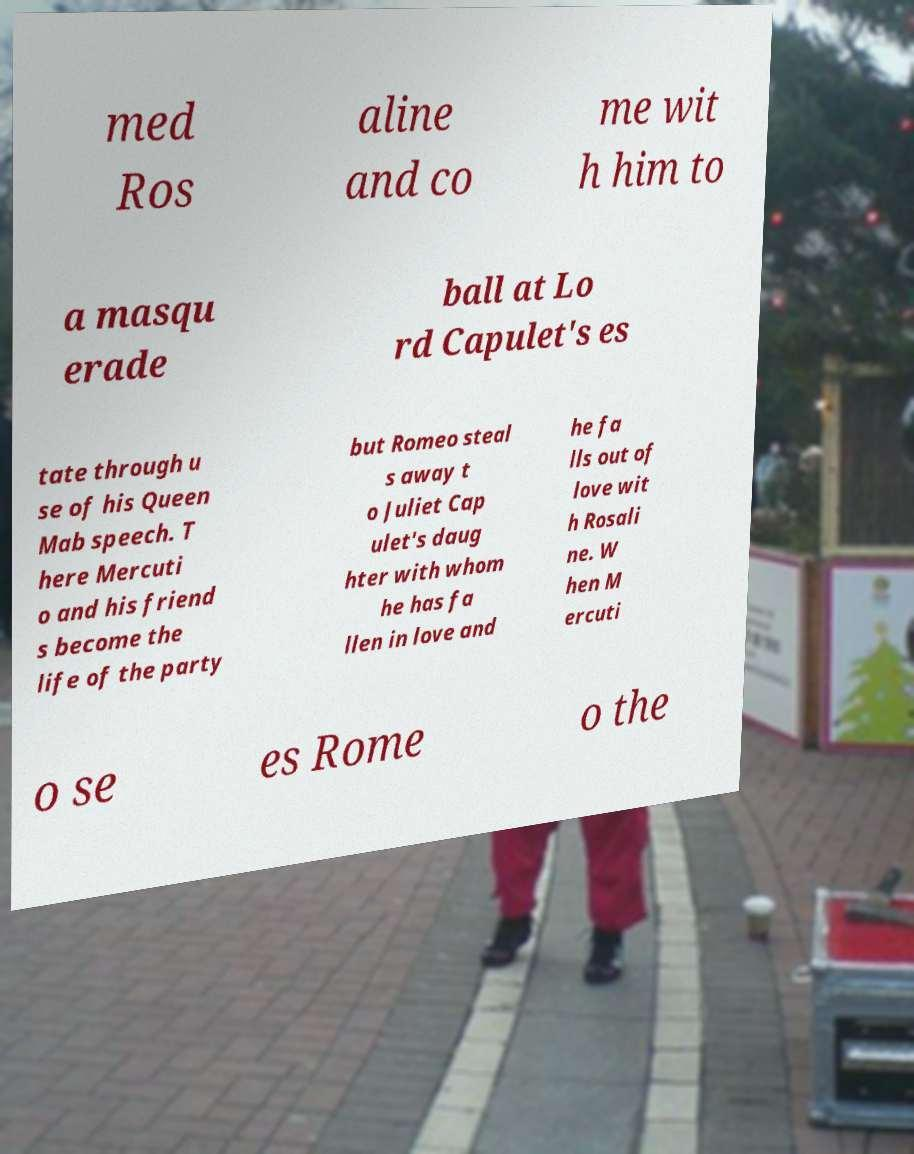Could you extract and type out the text from this image? med Ros aline and co me wit h him to a masqu erade ball at Lo rd Capulet's es tate through u se of his Queen Mab speech. T here Mercuti o and his friend s become the life of the party but Romeo steal s away t o Juliet Cap ulet's daug hter with whom he has fa llen in love and he fa lls out of love wit h Rosali ne. W hen M ercuti o se es Rome o the 